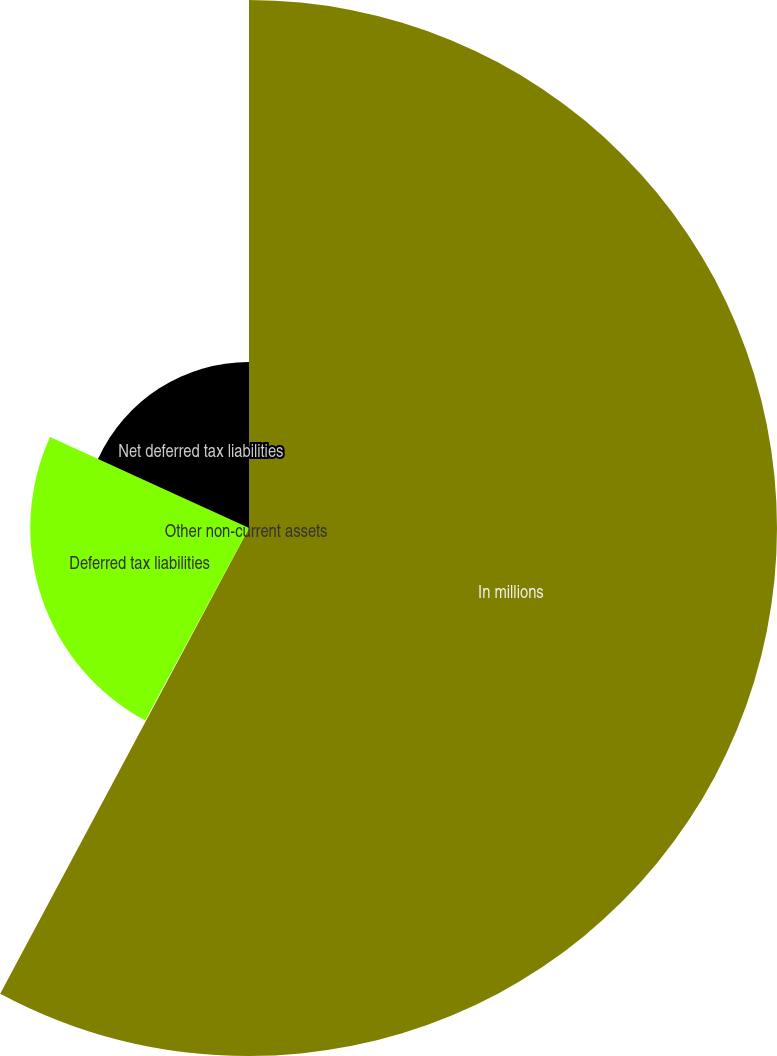Convert chart. <chart><loc_0><loc_0><loc_500><loc_500><pie_chart><fcel>In millions<fcel>Other non-current assets<fcel>Deferred tax liabilities<fcel>Net deferred tax liabilities<nl><fcel>57.81%<fcel>0.06%<fcel>23.95%<fcel>18.18%<nl></chart> 